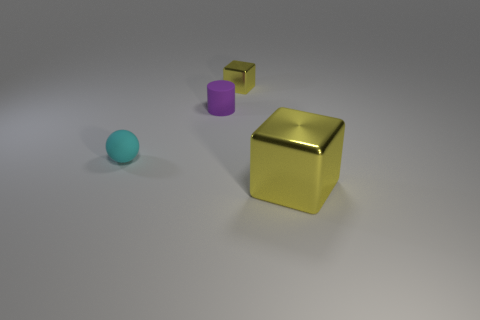Subtract all yellow balls. Subtract all yellow cylinders. How many balls are left? 1 Add 2 small yellow objects. How many objects exist? 6 Subtract all cylinders. How many objects are left? 3 Subtract all green shiny spheres. Subtract all shiny objects. How many objects are left? 2 Add 1 rubber cylinders. How many rubber cylinders are left? 2 Add 1 small yellow things. How many small yellow things exist? 2 Subtract 0 blue cubes. How many objects are left? 4 